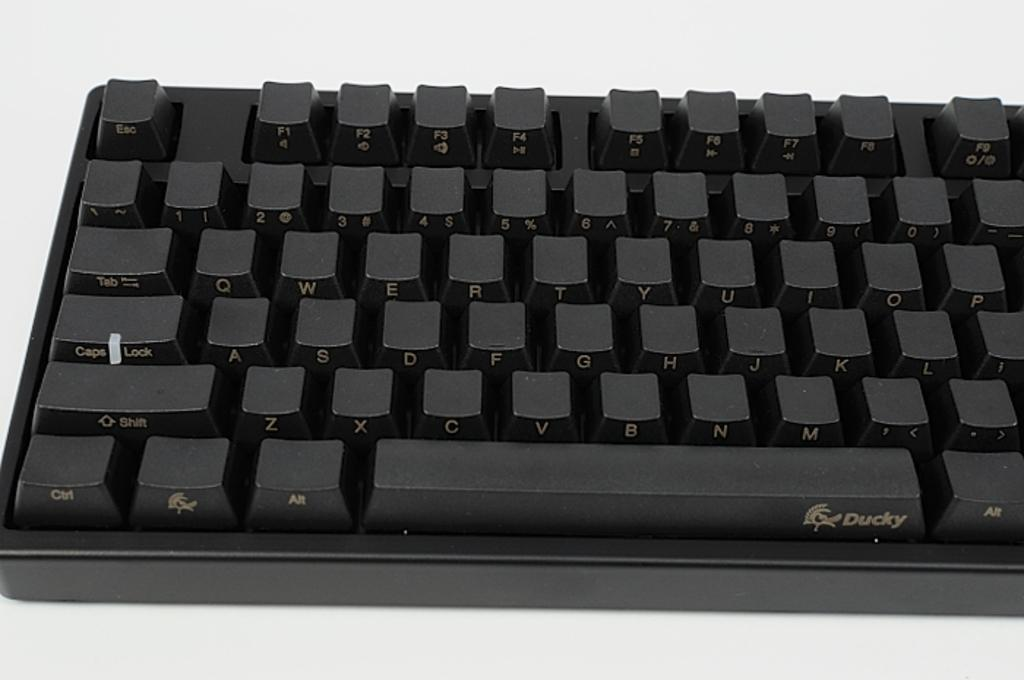<image>
Write a terse but informative summary of the picture. A computer keyboard made by the company Ducky 